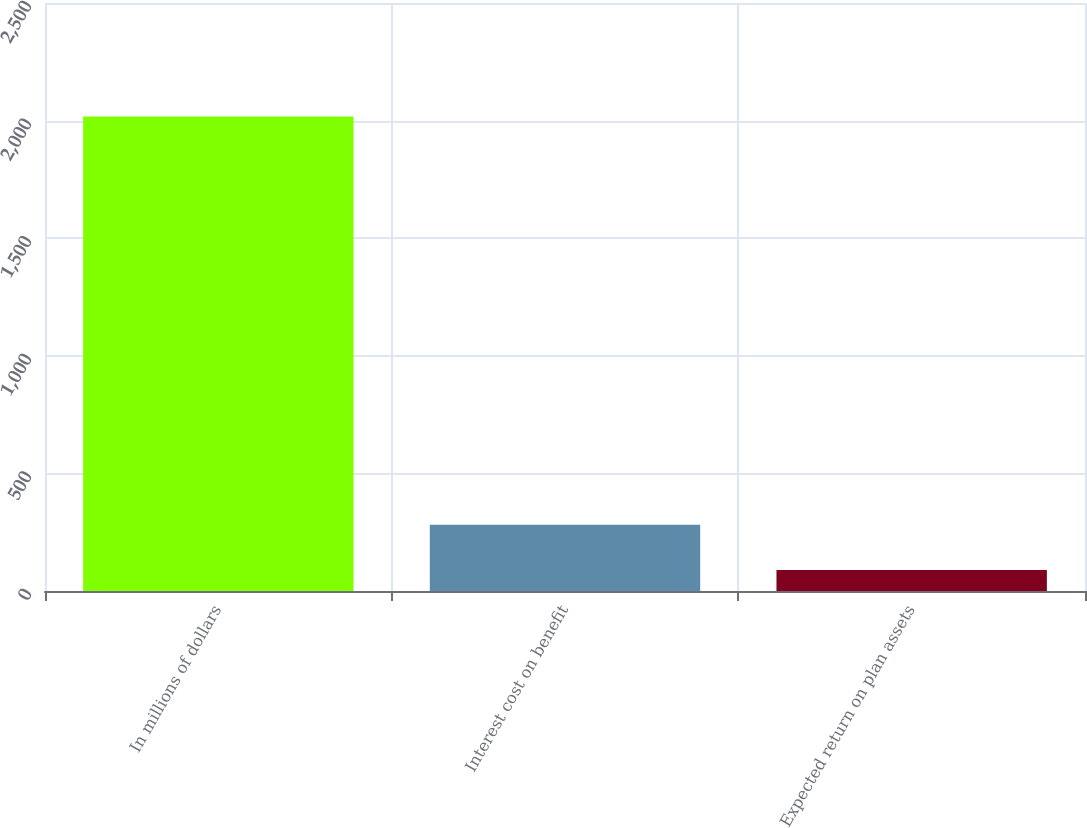Convert chart. <chart><loc_0><loc_0><loc_500><loc_500><bar_chart><fcel>In millions of dollars<fcel>Interest cost on benefit<fcel>Expected return on plan assets<nl><fcel>2017<fcel>281.8<fcel>89<nl></chart> 